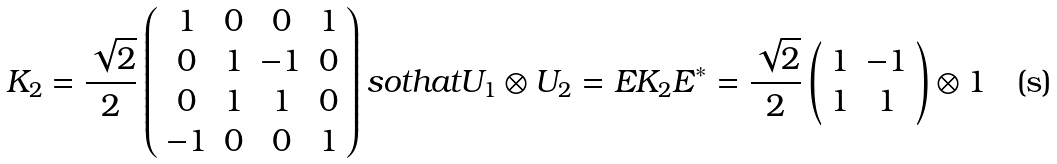<formula> <loc_0><loc_0><loc_500><loc_500>K _ { 2 } = \frac { \sqrt { 2 } } { 2 } \left ( \begin{array} { c c c c } 1 & 0 & 0 & 1 \\ 0 & 1 & - 1 & 0 \\ 0 & 1 & 1 & 0 \\ - 1 & 0 & 0 & 1 \\ \end{array} \right ) s o t h a t U _ { 1 } \otimes U _ { 2 } = E K _ { 2 } E ^ { * } = \frac { \sqrt { 2 } } { 2 } \left ( \begin{array} { c c } 1 & - 1 \\ 1 & 1 \\ \end{array} \right ) \otimes { 1 }</formula> 